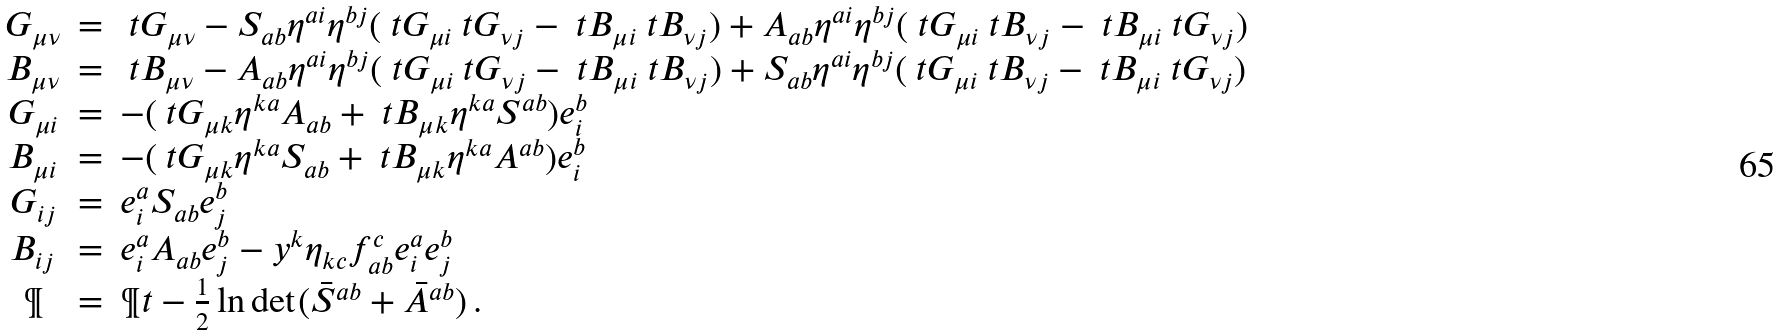Convert formula to latex. <formula><loc_0><loc_0><loc_500><loc_500>\begin{array} { c c l } G _ { \mu \nu } & = & \ t { G } _ { \mu \nu } - S _ { a b } \eta ^ { a i } \eta ^ { b j } ( \ t { G } _ { \mu i } \ t { G } _ { \nu j } - \ t { B } _ { \mu i } \ t { B } _ { \nu j } ) + A _ { a b } \eta ^ { a i } \eta ^ { b j } ( \ t { G } _ { \mu i } \ t { B } _ { \nu j } - \ t { B } _ { \mu i } \ t { G } _ { \nu j } ) \\ B _ { \mu \nu } & = & \ t { B } _ { \mu \nu } - A _ { a b } \eta ^ { a i } \eta ^ { b j } ( \ t { G } _ { \mu i } \ t { G } _ { \nu j } - \ t { B } _ { \mu i } \ t { B } _ { \nu j } ) + S _ { a b } \eta ^ { a i } \eta ^ { b j } ( \ t { G } _ { \mu i } \ t { B } _ { \nu j } - \ t { B } _ { \mu i } \ t { G } _ { \nu j } ) \\ G _ { \mu i } & = & - ( \ t { G } _ { \mu k } \eta ^ { k a } A _ { a b } + \ t { B } _ { \mu k } \eta ^ { k a } S ^ { a b } ) e ^ { b } _ { i } \\ B _ { \mu i } & = & - ( \ t { G } _ { \mu k } \eta ^ { k a } S _ { a b } + \ t { B } _ { \mu k } \eta ^ { k a } A ^ { a b } ) e ^ { b } _ { i } \\ G _ { i j } & = & e _ { i } ^ { a } S _ { a b } e ^ { b } _ { j } \\ B _ { i j } & = & e _ { i } ^ { a } A _ { a b } e ^ { b } _ { j } - y ^ { k } \eta _ { k c } f ^ { c } _ { a b } e ^ { a } _ { i } e ^ { b } _ { j } \\ \P & = & \P t - \frac { 1 } { 2 } \ln \det ( \bar { S } ^ { a b } + \bar { A } ^ { a b } ) \, . \end{array}</formula> 